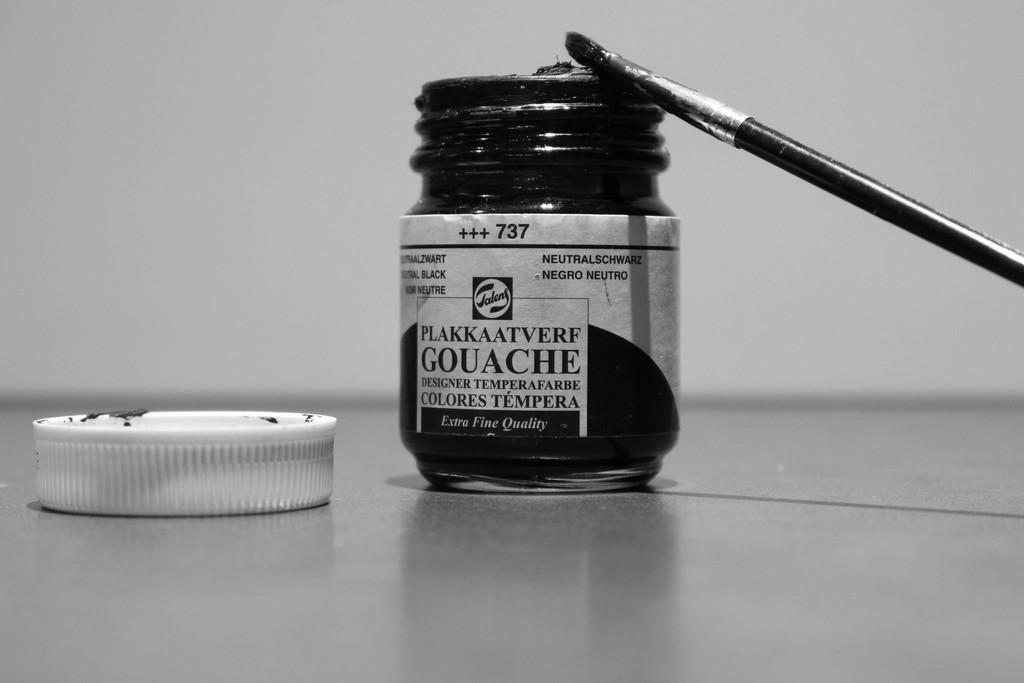<image>
Give a short and clear explanation of the subsequent image. A bottle of black Extra Fine Quality ink with a brush on top of it. 